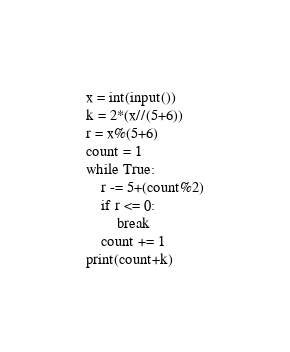Convert code to text. <code><loc_0><loc_0><loc_500><loc_500><_Python_>x = int(input())
k = 2*(x//(5+6))
r = x%(5+6)
count = 1
while True:
    r -= 5+(count%2)
    if r <= 0:
        break
    count += 1
print(count+k)</code> 